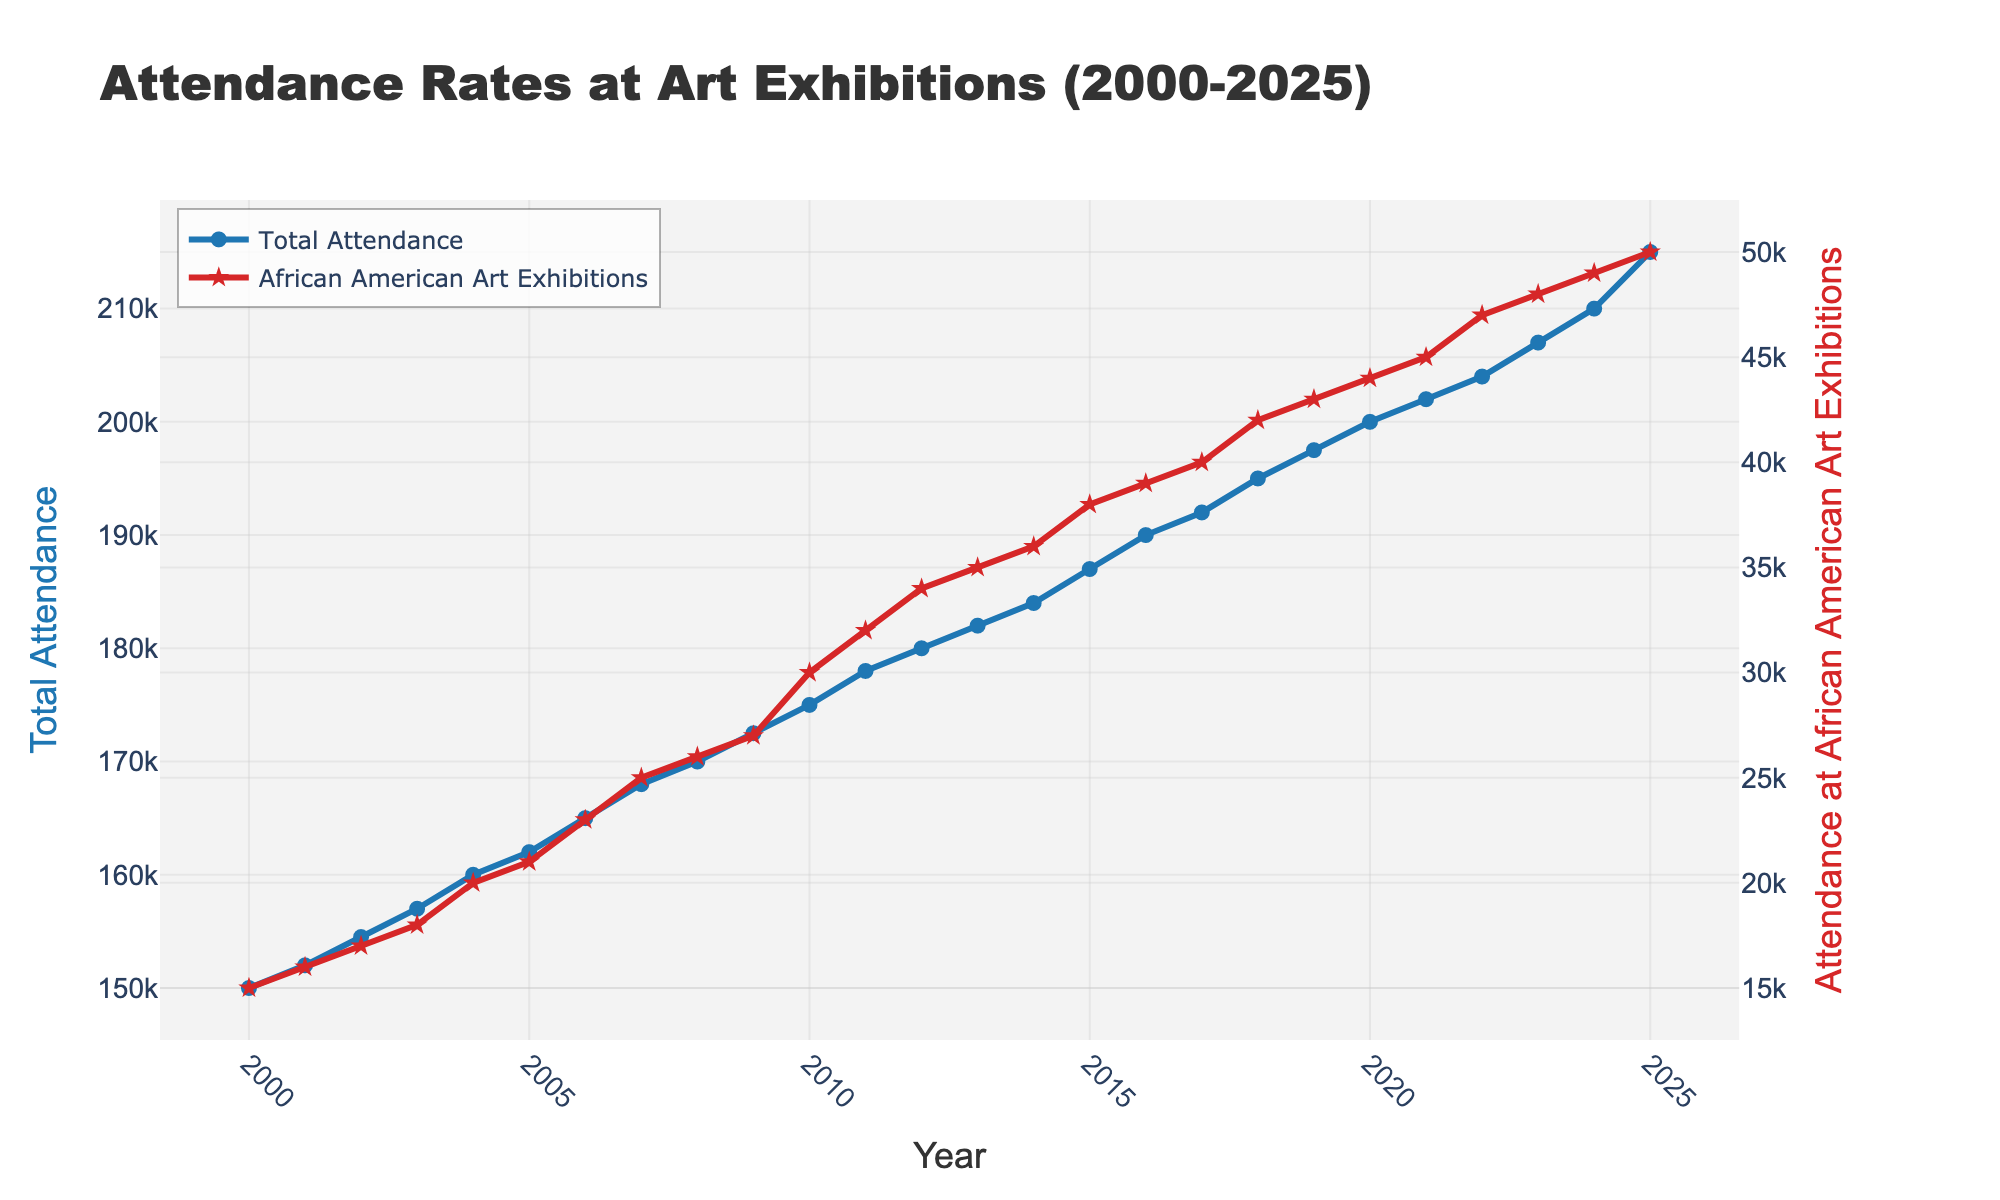What is the title of the plot? The title of the plot is prominently displayed at the top of the figure. It serves as a summary of the content presented.
Answer: Attendance Rates at Art Exhibitions (2000-2025) What do the red and blue lines represent? The legend indicates the meanings of the lines: the red line shows "Attendance at African American Art Exhibitions," and the blue line represents "Total Attendance."
Answer: The red line represents "Attendance at African American Art Exhibitions," and the blue line represents "Total Attendance." What is the total attendance in 2010? The blue line indicates total attendance, and by checking the year 2010 on the x-axis, we can read the corresponding y-value.
Answer: 175,000 In which year was the attendance at African American art exhibitions highest? By identifying the peak value on the red line and referring to the x-axis, we can determine the year when the attendance was highest.
Answer: 2025 How does the attendance at African American art exhibitions change from 2000 to 2025? The red line shows an upward trend from 2000 to 2025, indicating growth in attendance at African American art exhibitions over time.
Answer: It increases What is the percentage increase in total attendance from 2000 to 2025? Calculate the difference: 215,000 - 150,000 = 65,000. Then find the percentage increase: (65,000 / 150,000) * 100 = approximately 43.33%
Answer: Approximately 43.33% In which year is the gap widest between total attendance and attendance at African American art exhibitions? Identify the year where the difference between the values of the blue and red lines is greatest by comparing year-over-year.
Answer: 2000 What is the total attendance in 2023, and how does it compare to 2000? Refer to both years on the x-axis and read their respective y-values from the blue line: 2023 - 207,000 and 2000 - 150,000. Compare these values.
Answer: It increased by 57,000 What is the average annual increase in attendance at African American art exhibitions from 2000 to 2025? Calculate the total increase: 50,000 - 15,000 = 35,000. Then divide by the number of years (2025 - 2000 = 25): 35,000 / 25 = 1,400.
Answer: 1,400 per year Do both attendance figures show a constant rate of increase? By examining the slope and consistency of both lines, we can see if both attendance figures increase uniformly year-over-year.
Answer: No, the rates fluctuate 